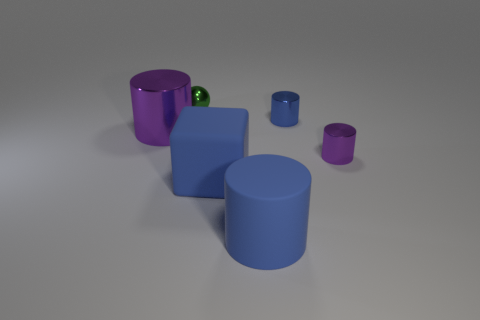How many blue cylinders must be subtracted to get 1 blue cylinders? 1 Subtract all small purple metallic cylinders. How many cylinders are left? 3 Subtract all purple cylinders. How many cylinders are left? 2 Subtract 0 green cylinders. How many objects are left? 6 Subtract all balls. How many objects are left? 5 Subtract 1 cylinders. How many cylinders are left? 3 Subtract all green cylinders. Subtract all brown cubes. How many cylinders are left? 4 Subtract all gray cubes. How many cyan cylinders are left? 0 Subtract all rubber cylinders. Subtract all small blue things. How many objects are left? 4 Add 4 big purple cylinders. How many big purple cylinders are left? 5 